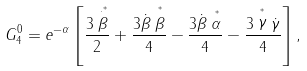<formula> <loc_0><loc_0><loc_500><loc_500>G ^ { 0 } _ { 4 } = e ^ { - \alpha } \left [ \frac { 3 \stackrel { \cdot ^ { * } } { \beta } } { 2 } + \frac { 3 \dot { \beta } \stackrel { ^ { * } } { \beta } } { 4 } - \frac { 3 \dot { \beta } \stackrel { ^ { * } } { \alpha } } { 4 } - \frac { 3 \stackrel { ^ { * } } { \gamma } \dot { \gamma } } { 4 } \right ] ,</formula> 